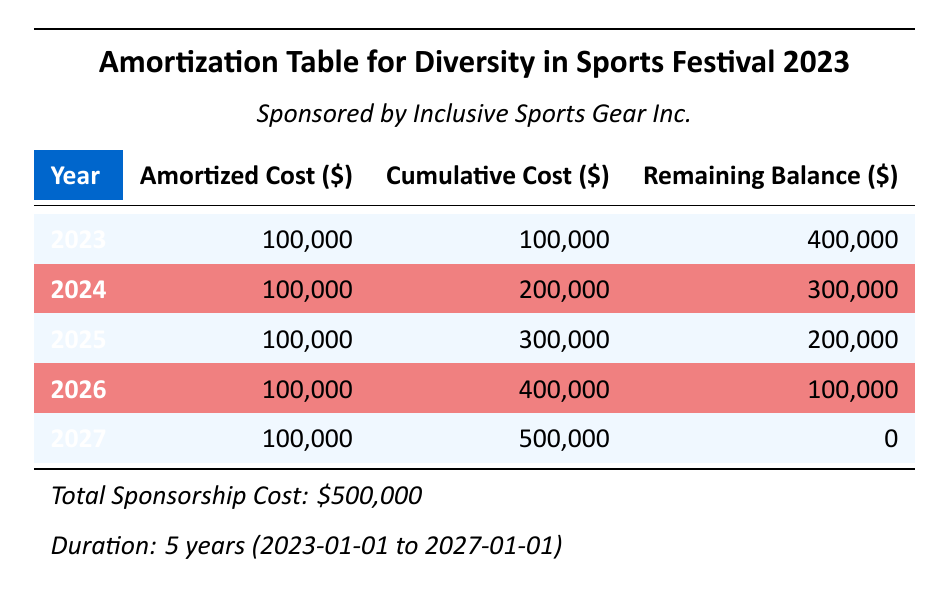What is the total cost of the sponsorship? The total cost is listed at the bottom of the table as \$500,000.
Answer: 500000 How much was the amortized cost for the year 2025? In the table, the amortized cost for 2025 is specified as \$100,000.
Answer: 100000 What will the cumulative cost be after 2026? The cumulative cost for 2026 is provided in the table as \$400,000.
Answer: 400000 Is the remaining balance at the end of 2024 higher than \$200,000? The remaining balance at the end of 2024 is \$300,000, which is indeed higher than \$200,000.
Answer: Yes How much did the cumulative cost increase from 2023 to 2026? The cumulative cost in 2023 is \$100,000 and in 2026 is \$400,000. The increase is \$400,000 - \$100,000 = \$300,000.
Answer: 300000 What is the average annual amortized cost over the duration of the sponsorship? The total amortized cost over 5 years is \$500,000. To find the average, divide by 5: \$500,000 / 5 = \$100,000.
Answer: 100000 What is the remaining balance at the end of the sponsorship period? The remaining balance at the end of 2027 is \$0, as indicated in the last row of the table.
Answer: 0 How many years does the sponsorship last? The sponsorship lasts from 2023 to 2027, which is a total of 5 years.
Answer: 5 Is the total cost of the sponsorship evenly distributed over the years? Yes, the amortized cost of \$100,000 each year shows that the total cost is distributed evenly across the 5 years.
Answer: Yes 